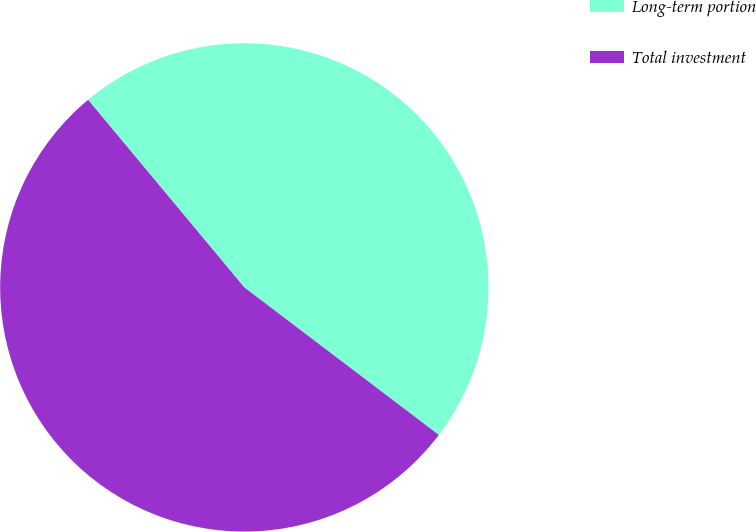Convert chart to OTSL. <chart><loc_0><loc_0><loc_500><loc_500><pie_chart><fcel>Long-term portion<fcel>Total investment<nl><fcel>46.38%<fcel>53.62%<nl></chart> 